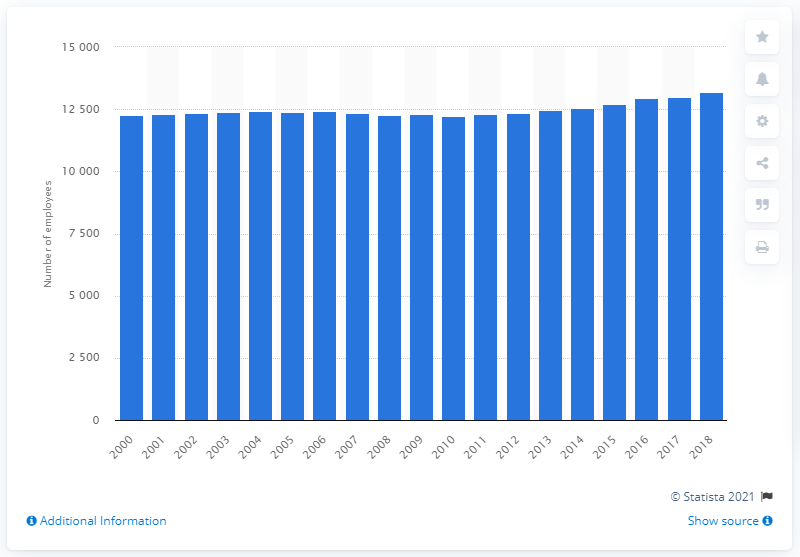Mention a couple of crucial points in this snapshot. In 2018, there were 13,178 general practitioners employed in Belgium. 